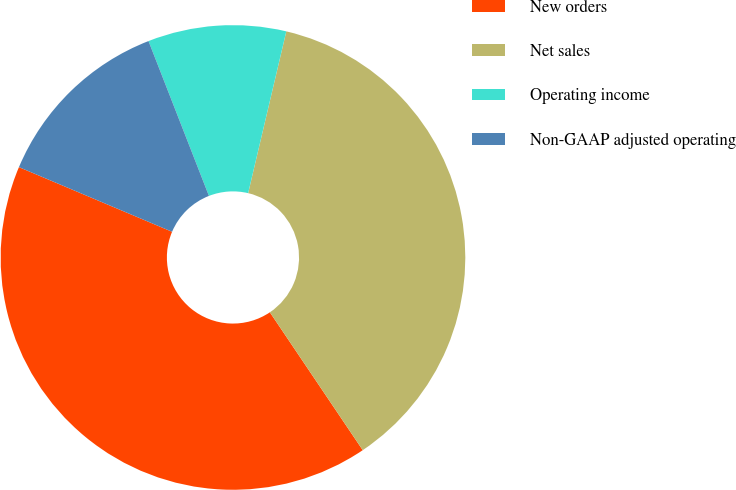Convert chart. <chart><loc_0><loc_0><loc_500><loc_500><pie_chart><fcel>New orders<fcel>Net sales<fcel>Operating income<fcel>Non-GAAP adjusted operating<nl><fcel>40.79%<fcel>36.88%<fcel>9.61%<fcel>12.72%<nl></chart> 